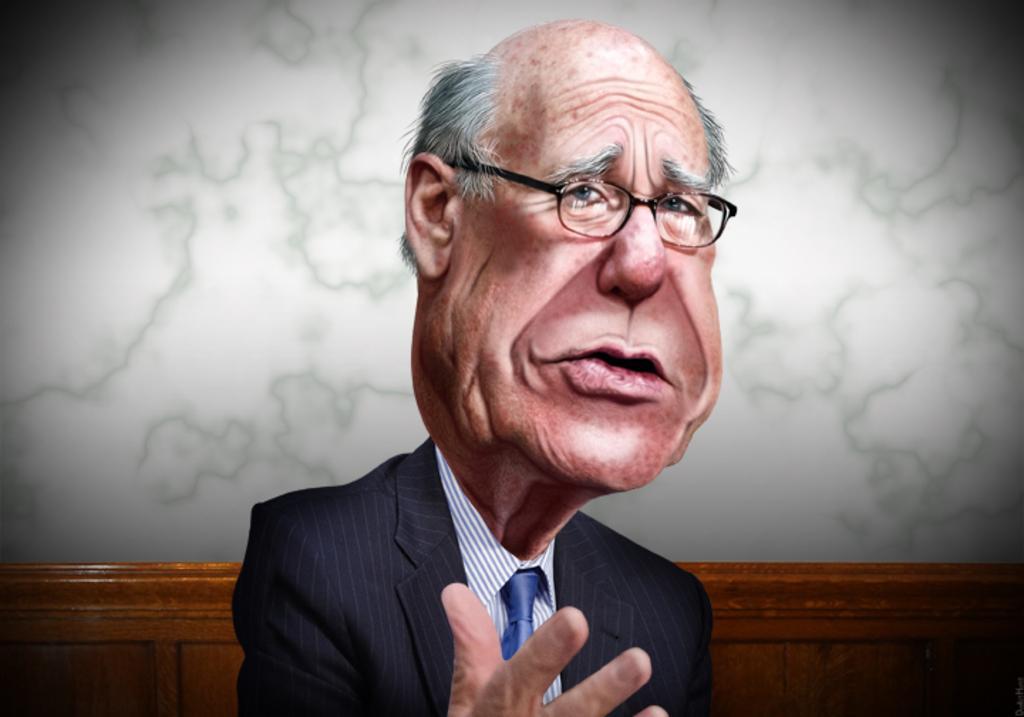In one or two sentences, can you explain what this image depicts? This is an animated image. In this picture, we see the man is wearing the spectacles and a black blazer. He is trying to talk something. Behind him, we see a wooden table or a bench. In the background, it is white in color. 